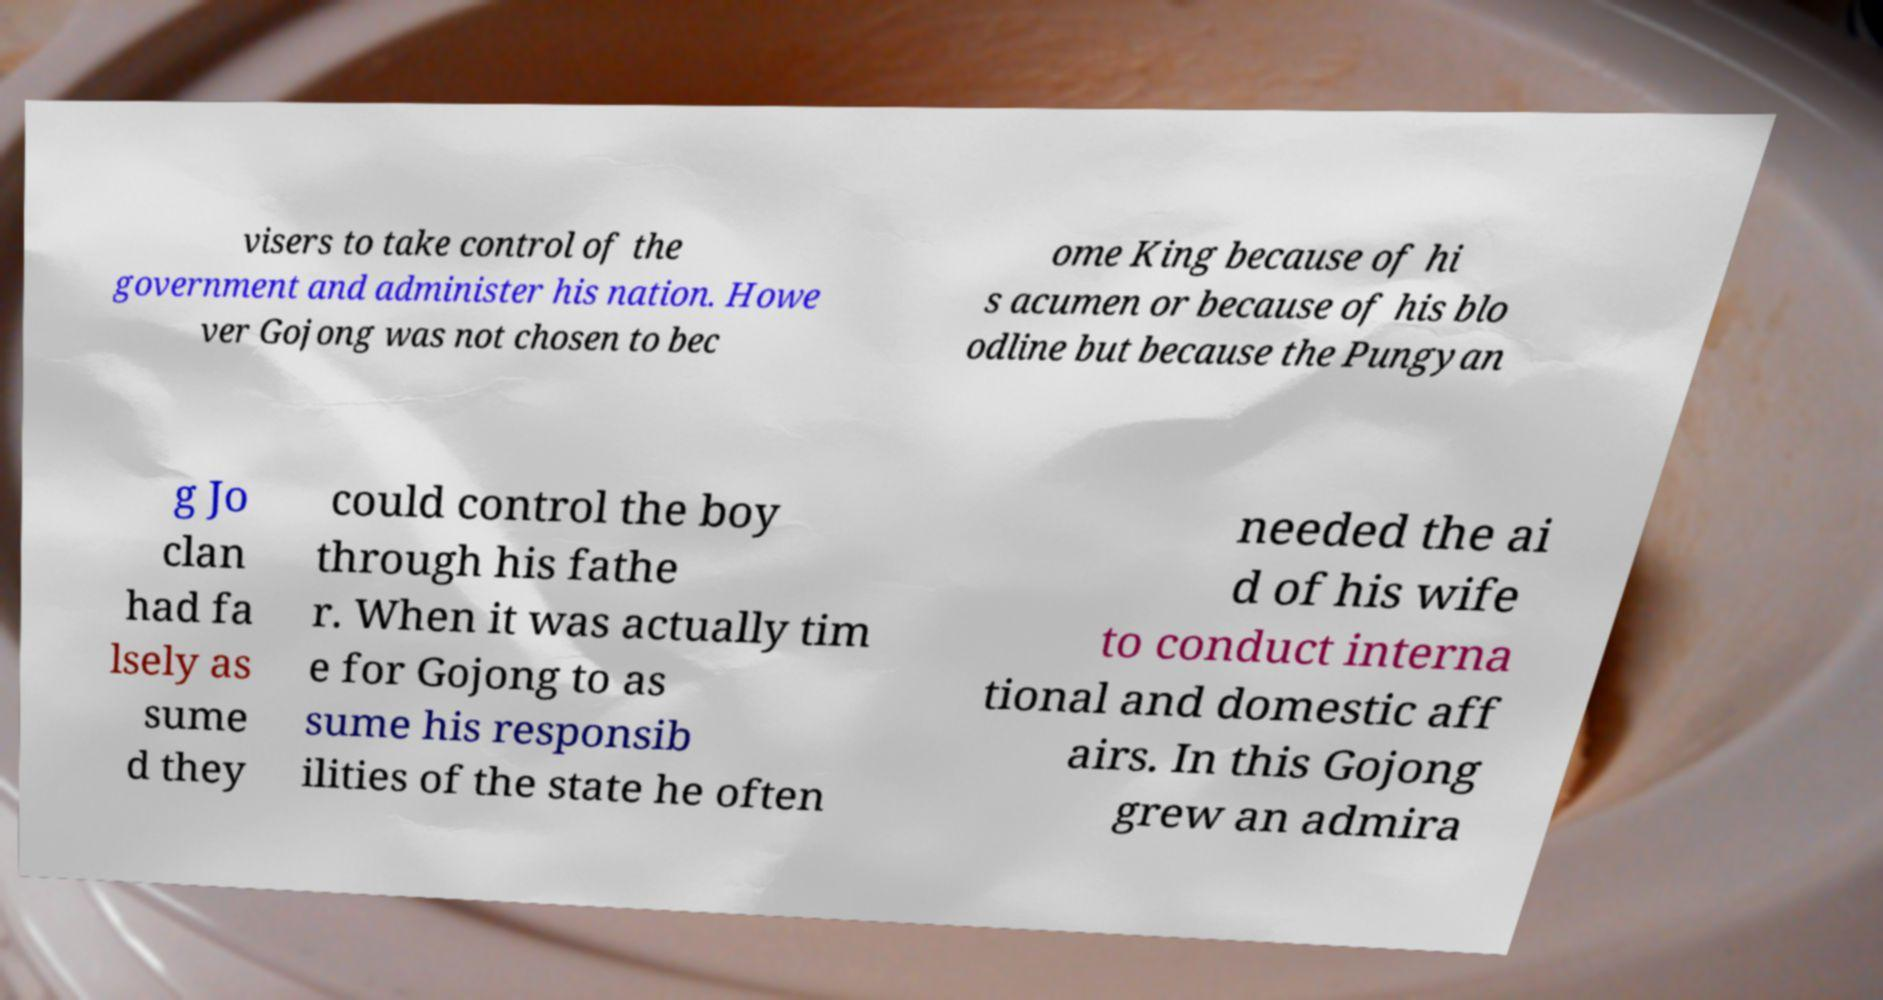Please identify and transcribe the text found in this image. visers to take control of the government and administer his nation. Howe ver Gojong was not chosen to bec ome King because of hi s acumen or because of his blo odline but because the Pungyan g Jo clan had fa lsely as sume d they could control the boy through his fathe r. When it was actually tim e for Gojong to as sume his responsib ilities of the state he often needed the ai d of his wife to conduct interna tional and domestic aff airs. In this Gojong grew an admira 